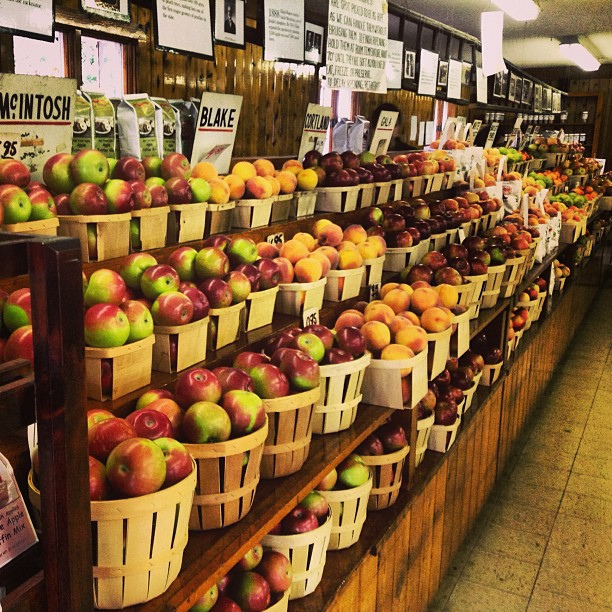Please transcribe the text in this image. BLAKE 95 MCINTOSH 